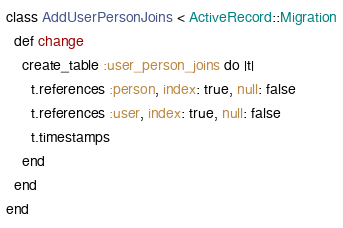Convert code to text. <code><loc_0><loc_0><loc_500><loc_500><_Ruby_>class AddUserPersonJoins < ActiveRecord::Migration
  def change
    create_table :user_person_joins do |t|
      t.references :person, index: true, null: false
      t.references :user, index: true, null: false
      t.timestamps
    end
  end
end
</code> 